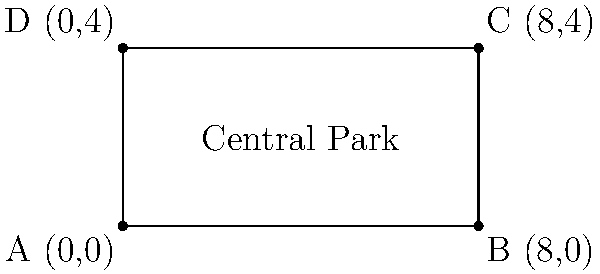As a long-time New Yorker, you're familiar with the iconic Central Park. Using the coordinate system shown, where each unit represents 0.25 miles, calculate the area of Central Park in square miles. The corners of the park are represented by points A(0,0), B(8,0), C(8,4), and D(0,4). Let's approach this step-by-step:

1) First, we need to recognize that Central Park forms a rectangle in this coordinate system.

2) To find the area of a rectangle, we use the formula: $$ \text{Area} = \text{length} \times \text{width} $$

3) The length of the park is the distance between points A and B (or D and C):
   $$ \text{length} = 8 \text{ units} $$

4) The width of the park is the distance between points A and D (or B and C):
   $$ \text{width} = 4 \text{ units} $$

5) Now we can calculate the area in square units:
   $$ \text{Area} = 8 \times 4 = 32 \text{ square units} $$

6) Remember that each unit represents 0.25 miles. To convert square units to square miles:
   $$ 32 \text{ square units} \times (0.25 \text{ miles/unit})^2 = 32 \times 0.0625 = 2 \text{ square miles} $$

Therefore, the area of Central Park based on these coordinates is 2 square miles.
Answer: 2 square miles 